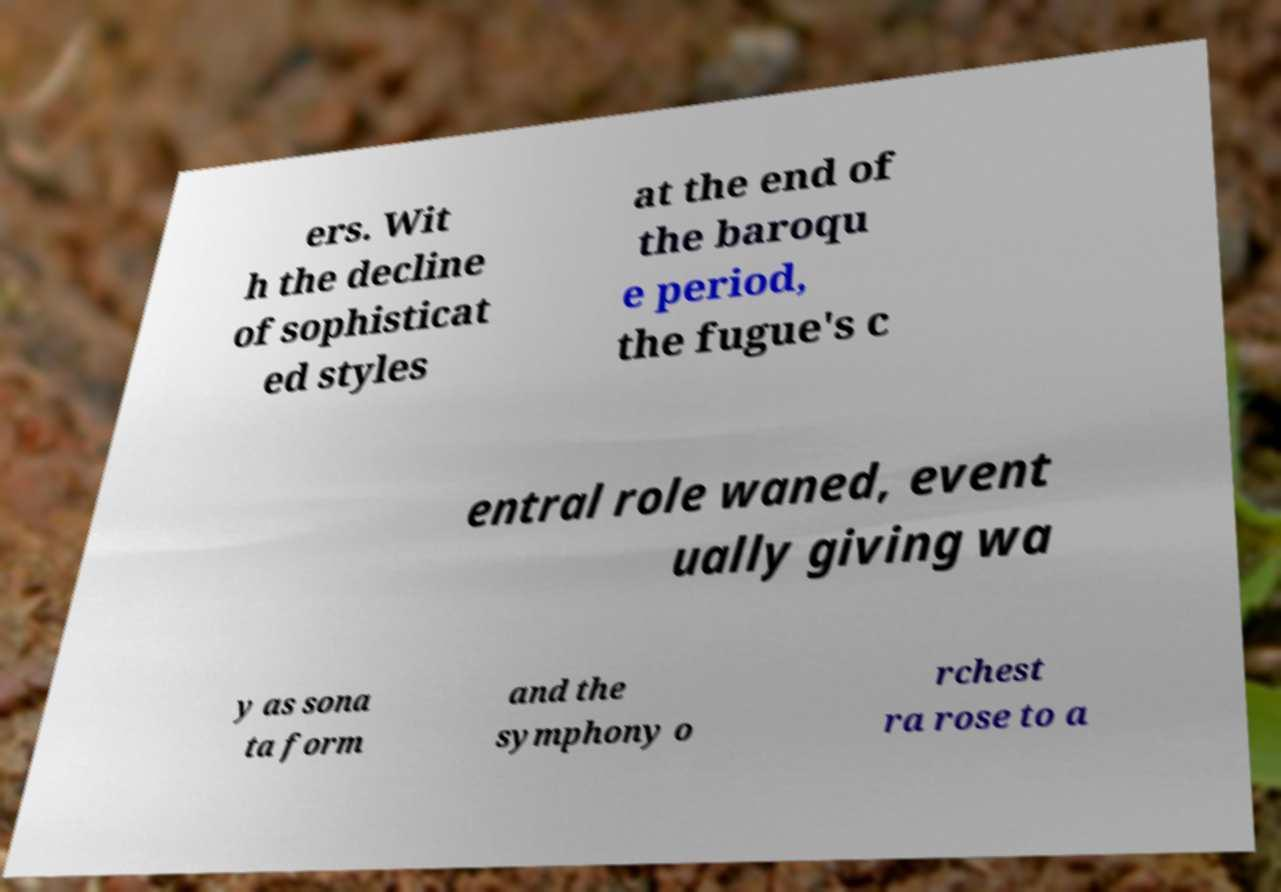Please identify and transcribe the text found in this image. ers. Wit h the decline of sophisticat ed styles at the end of the baroqu e period, the fugue's c entral role waned, event ually giving wa y as sona ta form and the symphony o rchest ra rose to a 